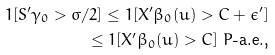Convert formula to latex. <formula><loc_0><loc_0><loc_500><loc_500>1 [ S ^ { \prime } \gamma _ { 0 } > \varsigma / 2 ] \leq 1 [ X ^ { \prime } \beta _ { 0 } ( u ) > C + \epsilon ^ { \prime } ] \\ \leq 1 [ X ^ { \prime } \beta _ { 0 } ( u ) > C ] \text { $P$-a.e.,}</formula> 